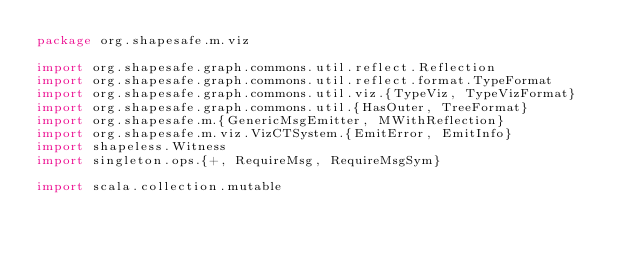Convert code to text. <code><loc_0><loc_0><loc_500><loc_500><_Scala_>package org.shapesafe.m.viz

import org.shapesafe.graph.commons.util.reflect.Reflection
import org.shapesafe.graph.commons.util.reflect.format.TypeFormat
import org.shapesafe.graph.commons.util.viz.{TypeViz, TypeVizFormat}
import org.shapesafe.graph.commons.util.{HasOuter, TreeFormat}
import org.shapesafe.m.{GenericMsgEmitter, MWithReflection}
import org.shapesafe.m.viz.VizCTSystem.{EmitError, EmitInfo}
import shapeless.Witness
import singleton.ops.{+, RequireMsg, RequireMsgSym}

import scala.collection.mutable</code> 